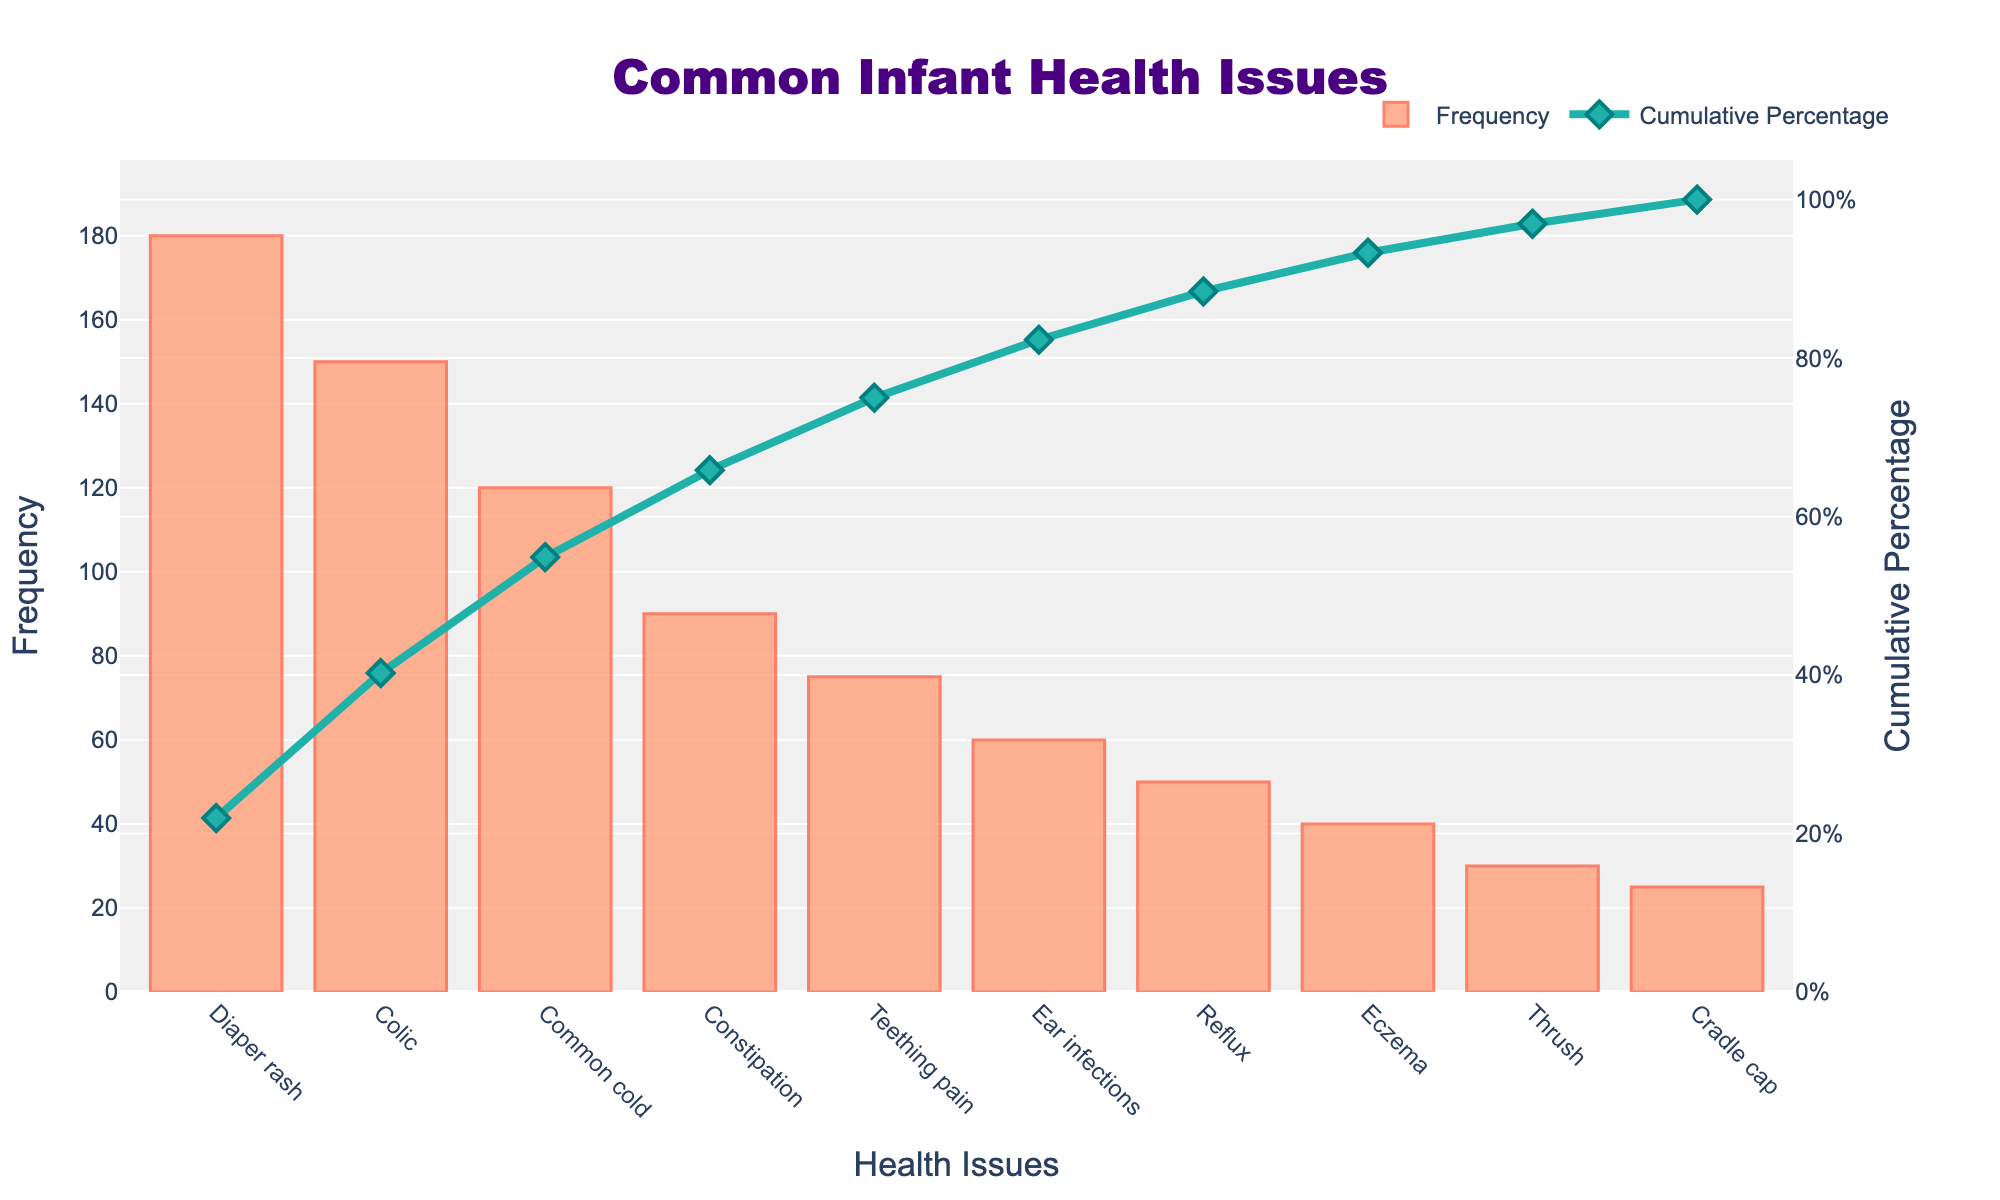What is the title of the chart? The title is often prominently displayed, usually at the top of a chart. In this case, the title is centered at the top.
Answer: Common Infant Health Issues Which health issue has the highest frequency? By looking at the bars, the tallest bar represents the health issue with the highest frequency. Here, "Diaper rash" has the highest frequency.
Answer: Diaper rash How many health issues have a frequency of 50 or more? Identify all bars that reach or exceed the 50 mark on the y-axis (Frequency). There are 7 such bars corresponding to "Diaper rash," "Colic," "Common cold," "Constipation," "Teething pain," "Ear infections," and "Reflux."
Answer: 7 What is the cumulative percentage for the top 3 most frequent health issues? Find the cumulative percentage line values for "Diaper rash," "Colic," and "Common cold." The cumulative percentages are around 31%, 56%, and 77%, respectively.
Answer: 77% Which issue is less frequent than "Reflux" but more frequent than "Thrush"? From the bar heights, compare frequencies and determine intermediates. "Eczema" lies between "Reflux" and "Thrush."
Answer: Eczema What is the frequency difference between the most and least common health issues? Subtract the frequency of the least common issue "Cradle cap" (25) from the most common "Diaper rash" (180).
Answer: 155 How many health issues account for nearly 80% of the cumulative percentage? Follow the cumulative percentage line to approximately 80%, which covers "Diaper rash," "Colic," "Common cold," "Constipation," and half "Teething pain." Count this total.
Answer: 4-5 What color is used for the bars representing frequency? The color observed on the bars is a variation of warm colors, identified as a shade of light orange or salmon.
Answer: Salmon Which issue's cumulative percentage crosses 50%? Track the cumulative percentage line to see at which issue it surpasses 50%. "Colic" achieves this mark.
Answer: Colic Is "Ear infections" more frequent than "Eczema"? By comparing their bar heights, “Ear infections,” which has a bar higher than "Eczema" (60 > 40), is more frequent.
Answer: Yes 